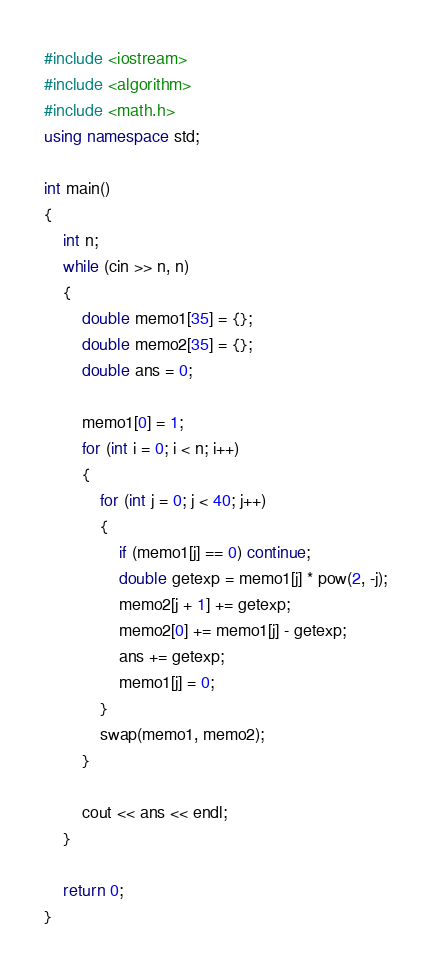Convert code to text. <code><loc_0><loc_0><loc_500><loc_500><_C++_>#include <iostream>
#include <algorithm>
#include <math.h>
using namespace std;

int main()
{
	int n;
	while (cin >> n, n)
	{
		double memo1[35] = {};
		double memo2[35] = {};
		double ans = 0;

		memo1[0] = 1;
		for (int i = 0; i < n; i++)
		{
			for (int j = 0; j < 40; j++)
			{
				if (memo1[j] == 0) continue;
				double getexp = memo1[j] * pow(2, -j);
				memo2[j + 1] += getexp;
				memo2[0] += memo1[j] - getexp;
				ans += getexp;
				memo1[j] = 0;
			}
			swap(memo1, memo2);
		}

		cout << ans << endl;
	}

	return 0;
}</code> 